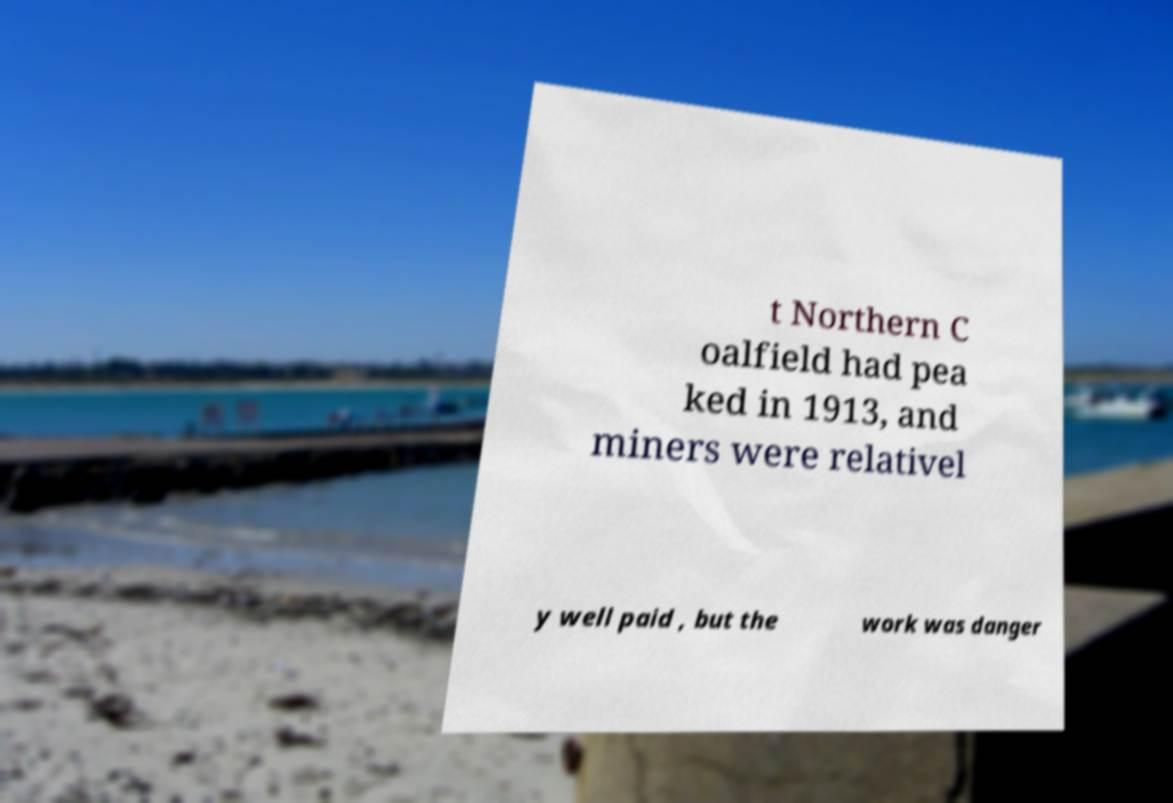Please identify and transcribe the text found in this image. t Northern C oalfield had pea ked in 1913, and miners were relativel y well paid , but the work was danger 